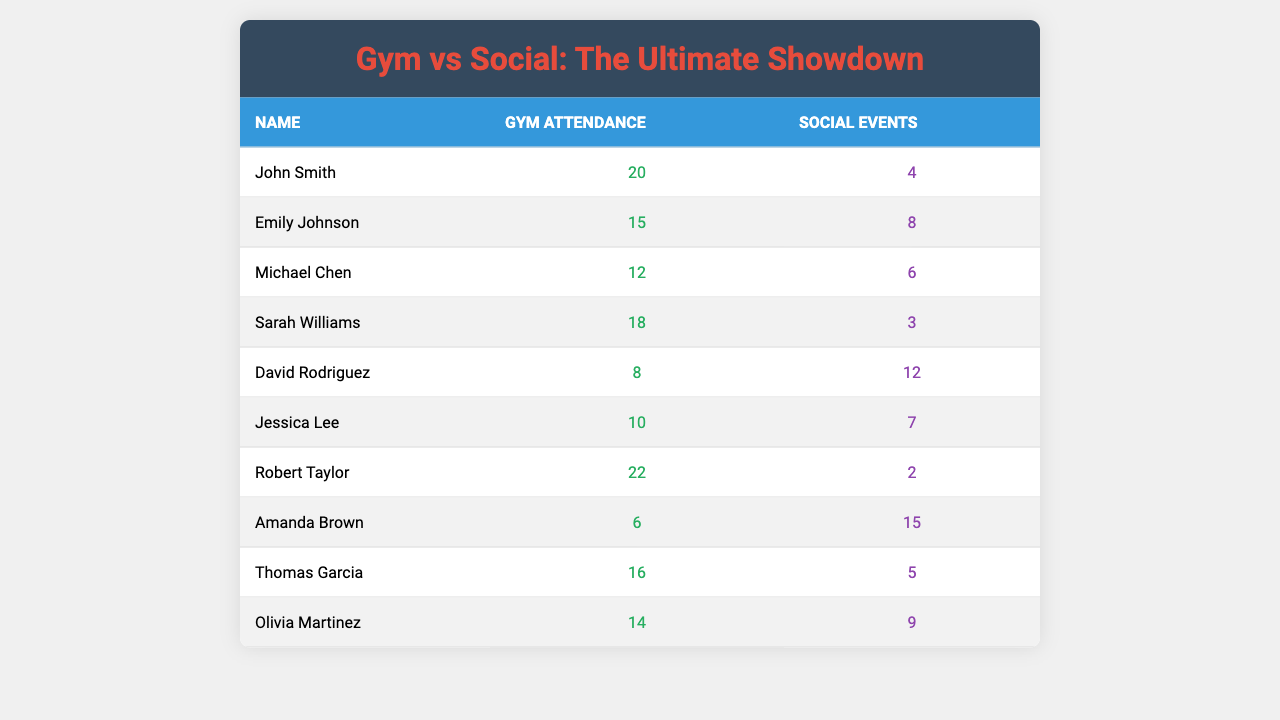What is the maximum number of gym attendances recorded? The table shows that Robert Taylor has the highest gym attendance with 22 visits.
Answer: 22 Who has the least number of social events attended? Amanda Brown attended the fewest social events, with a total of 15.
Answer: 15 How many people attended more social events than John Smith? John Smith attended 4 social events; David Rodriguez, Amanda Brown, and Olivia Martinez attended more than him (12, 15, and 9 respectively). This makes 4 people who attended more social events than John.
Answer: 4 What is the difference between the highest and lowest gym attendance? The highest attendance is 22 (Robert Taylor) and the lowest is 6 (Amanda Brown). The difference is calculated as 22 - 6 = 16.
Answer: 16 Is it true that Sarah Williams attended more social events than gym sessions? Sarah Williams attended 18 gym sessions and 3 social events. Thus, it is false that she attended more social events than gym sessions.
Answer: No What is the average gym attendance for the group? The total gym attendance is 20 + 15 + 12 + 18 + 8 + 10 + 22 + 6 + 16 + 14 = 151, and there are 10 individuals, hence the average is 151/10 = 15.1.
Answer: 15.1 How many individuals have a gym attendance less than 10? The table shows Amanda Brown with 6 and David Rodriguez with 8, so 2 individuals have less than 10 gym attendances.
Answer: 2 Which individual attended the most social events and how many did they attend? Amanda Brown attended the most social events with a count of 15, which is detailed in the table.
Answer: Amanda Brown, 15 events What is the total number of social events attended by individuals who went to the gym 15 times or more? The individuals with 15 or more gym attendances are John Smith (4 events), Emily Johnson (8 events), Robert Taylor (2 events), and Thomas Garcia (5 events). This gives a total of 4 + 8 + 2 + 5 = 19 social events.
Answer: 19 What percentage of social events attended by all individuals did David Rodriguez account for? David attended 12 social events, and the total number is 4 + 8 + 6 + 3 + 12 + 7 + 2 + 15 + 5 + 9 = 71. The percentage is (12/71) * 100 ≈ 16.9%.
Answer: 16.9% 